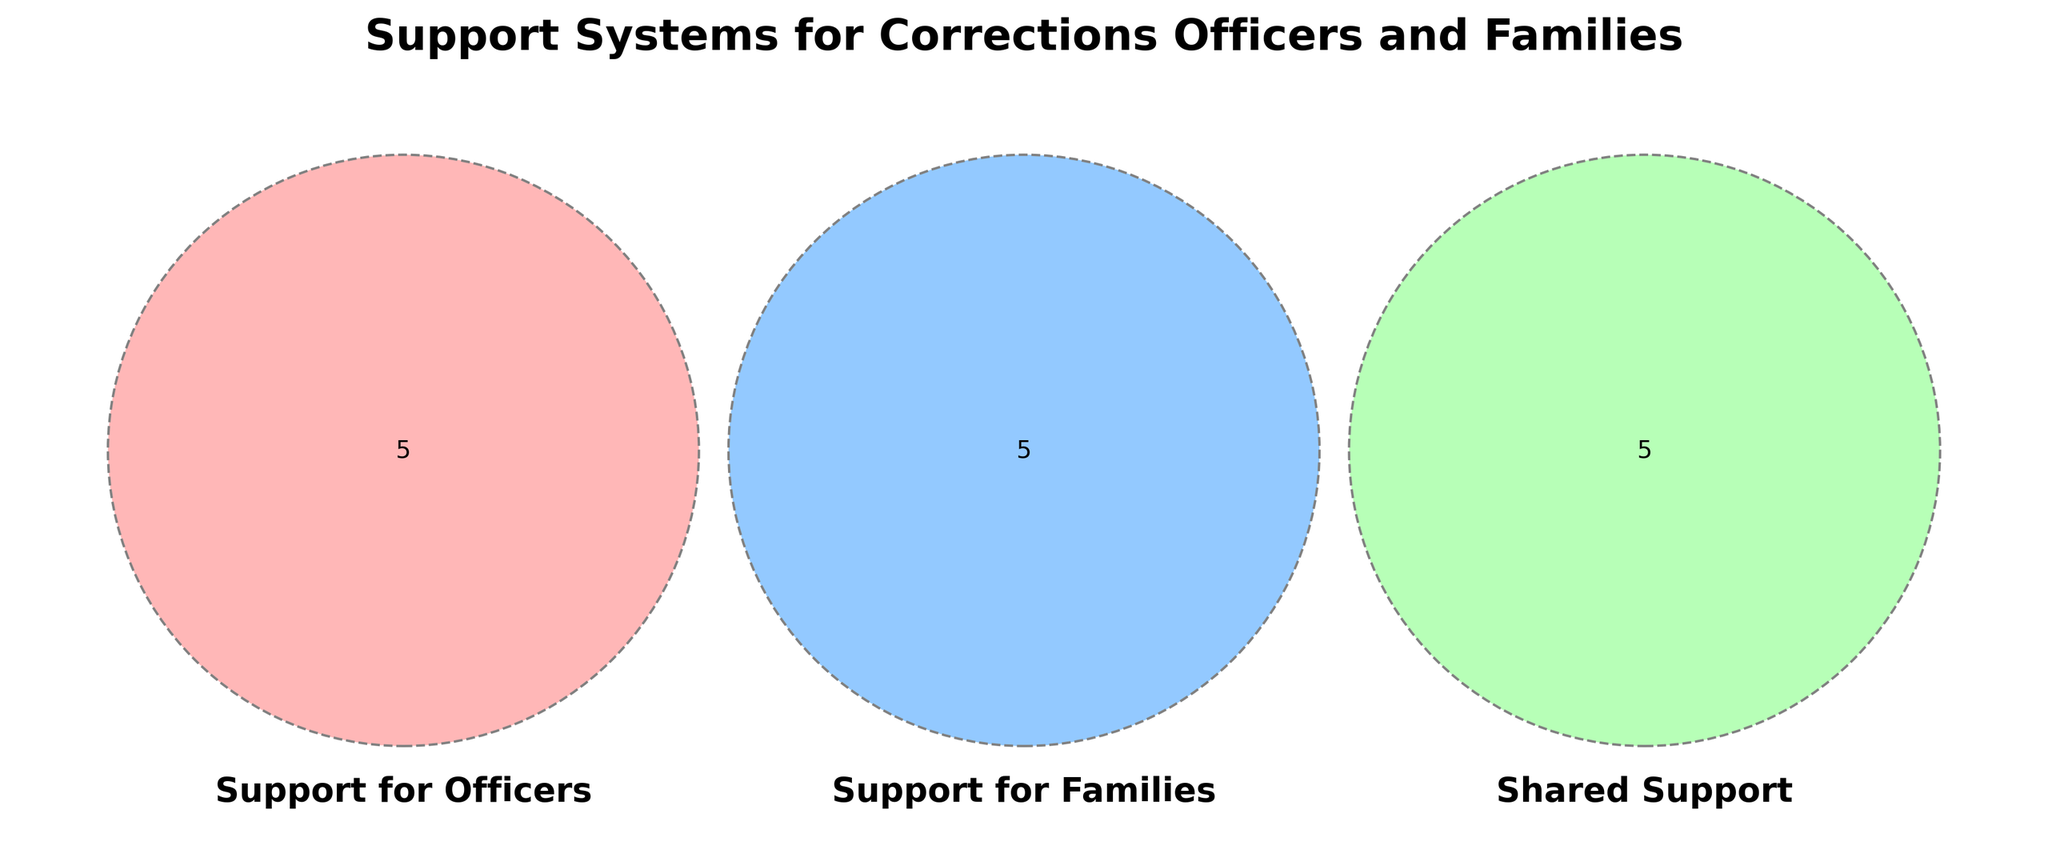Which types of support are shared between officers and their families? The shared support elements are those that appear in the overlapping area of the Venn diagram. These include Employee Assistance Program, Health Insurance, Financial Planning, Retirement Planning, and Mental Health Coverage.
Answer: Employee Assistance Program, Health Insurance, Financial Planning, Retirement Planning, Mental Health Coverage How many unique support elements are specifically for families? This is determined by counting the unique items in the "Support for Families" section that do not overlap with the other sets. These are Family Therapy, Child Care Services, Spouse Support Groups, Education Assistance, and Family Events.
Answer: 5 Which category has the most unique support activities? Count the number of activities unique to each category: the 'Officers' category has Counseling Hotline, Peer Support Groups, Stress Management Training, Critical Incident Debriefing, and Fitness Programs totaling 5; the 'Families' category has Family Therapy, Child Care Services, Spouse Support Groups, Education Assistance, and Family Events totaling 5; and 'Shared Support' has the same number. Since the count is equal for all categories, all categories have the same number of unique support activities.
Answer: All categories have the same number of unique support activities Which support system is found in all categories? Identify the elements that appear in the overlapping part of the Venn diagram. All shared support systems are common to both "Support for Officers" and "Support for Families".
Answer: There is no support system found in all categories as there isn’t a central overlap in the provided details What is the total number of support activities listed in the entire diagram? Add up the unique support activities from all sections, ensuring no double-counting of shared activities: 5 (Officers) + 5 (Families) + 5 (Shared). 10 unique activities plus 5 shared.
Answer: 15 Is 'Fitness Programs' a type of support for families? Look at the Venn diagram to see where 'Fitness Programs' is listed. It is listed under the "Support for Officers" category only, not the "Support for Families" section.
Answer: No What types of therapy are included in the support systems? Identify all therapy-related support systems across all sections. Family Therapy is under "Support for Families" and Counseling Hotline falls under "Support for Officers".
Answer: Counseling Hotline, Family Therapy How many categories include Financial Planning as support? Check the Venn diagram to see where 'Financial Planning' is listed. It is in the overlapping section between 'Support for Officers' and 'Support for Families'.
Answer: 2 Which support is provided exclusively for officers but not families? Identify support systems listed in the ‘Support for Officers’ section that do not appear in the ‘Support for Families’. These are Counseling Hotline, Peer Support Groups, Stress Management Training, Critical Incident Debriefing, and Fitness Programs.
Answer: Counseling Hotline, Peer Support Groups, Stress Management Training, Critical Incident Debriefing, Fitness Programs 